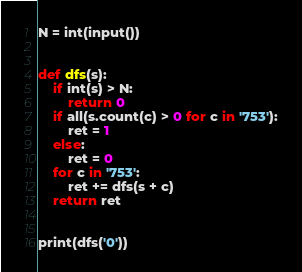Convert code to text. <code><loc_0><loc_0><loc_500><loc_500><_Python_>N = int(input())


def dfs(s):
    if int(s) > N:
        return 0
    if all(s.count(c) > 0 for c in '753'):
        ret = 1
    else:
        ret = 0
    for c in '753':
        ret += dfs(s + c)
    return ret


print(dfs('0'))</code> 